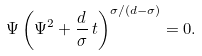<formula> <loc_0><loc_0><loc_500><loc_500>\Psi \left ( \Psi ^ { 2 } + \frac { d } { \sigma } \, t \right ) ^ { \sigma / ( d - \sigma ) } = 0 .</formula> 